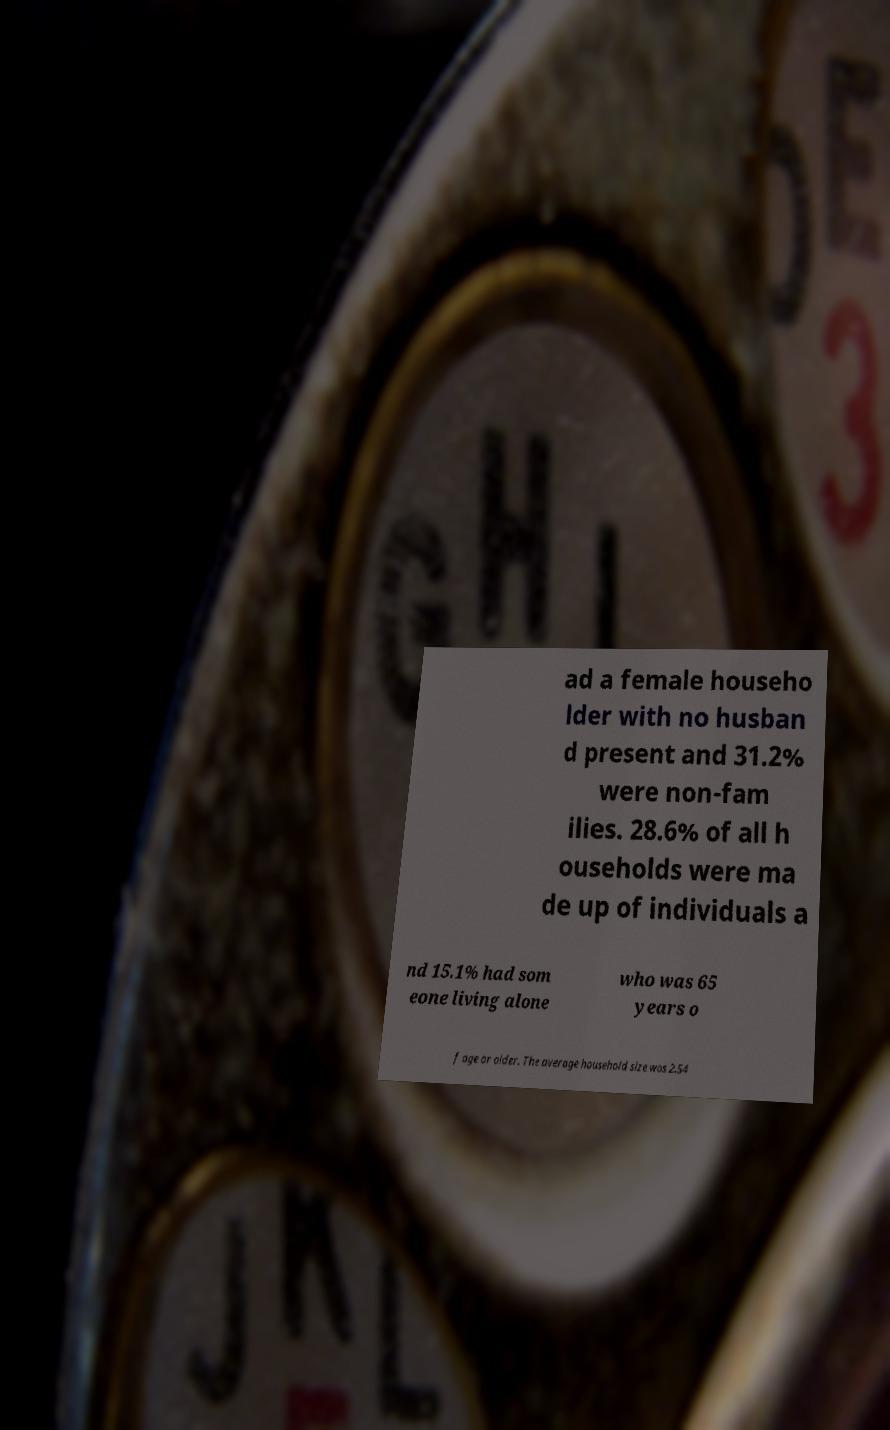Could you assist in decoding the text presented in this image and type it out clearly? ad a female househo lder with no husban d present and 31.2% were non-fam ilies. 28.6% of all h ouseholds were ma de up of individuals a nd 15.1% had som eone living alone who was 65 years o f age or older. The average household size was 2.54 